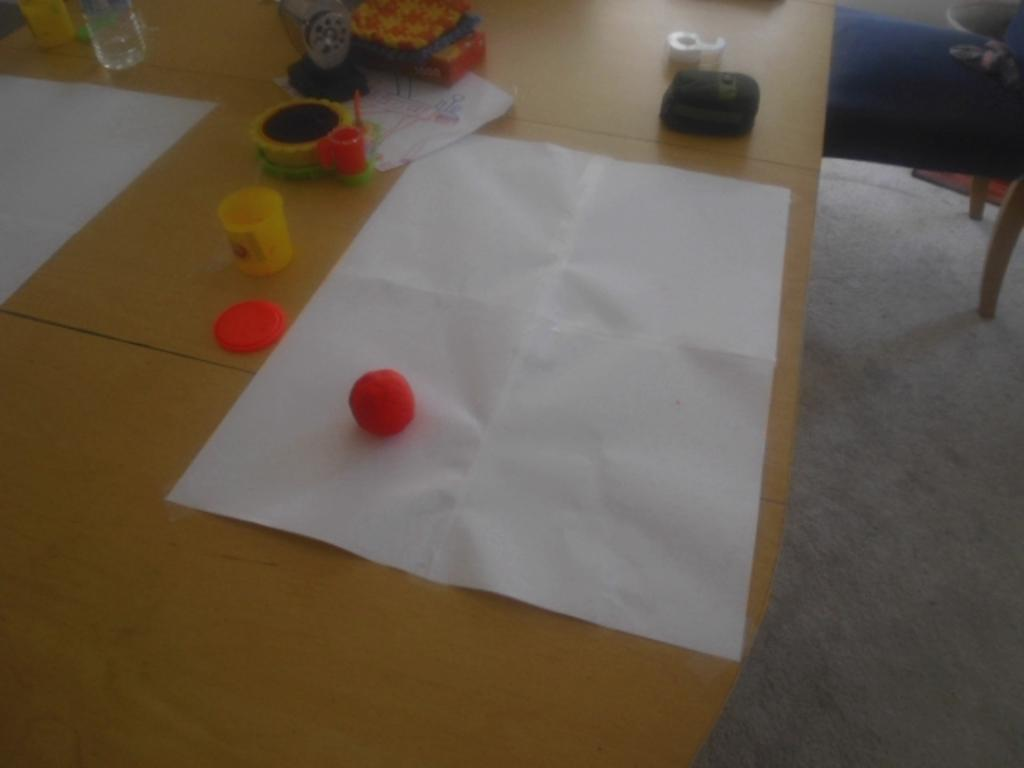What is placed on the table in the image? There is a paper on the table. What else can be seen on the table? There is a bottle on the table. Can you describe any other objects on the table? There are other things on the table, but their specific details are not mentioned in the provided facts. What type of apple is being used in the fight scene in the image? There is no apple or fight scene present in the image. What type of tank is visible in the background of the image? There is no tank visible in the image; it only features a table with a paper and a bottle on it. 